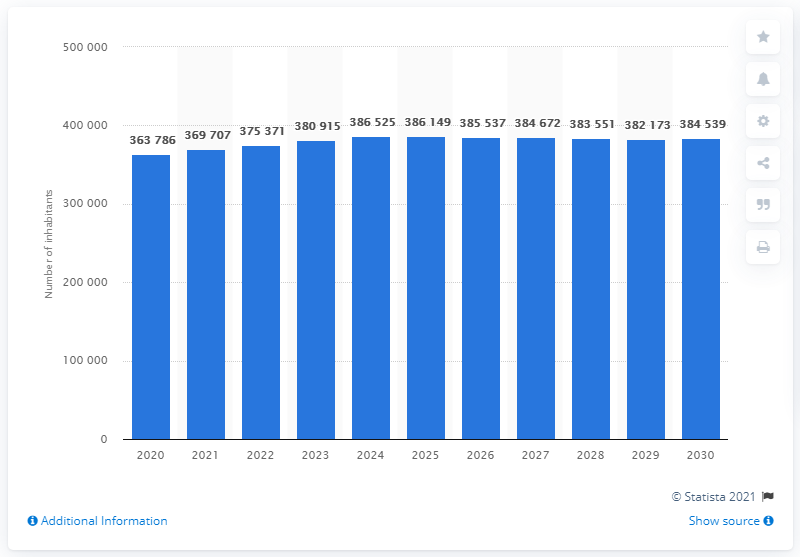What factors might contribute to the steady population growth in Iceland as shown in the graph? Several factors may contribute to the steady population growth in Iceland, including a stable economy, high quality of life, and strong healthcare systems. Additionally, Iceland's government policies promoting family life and sustainable living could also be influencing these positive trends. 